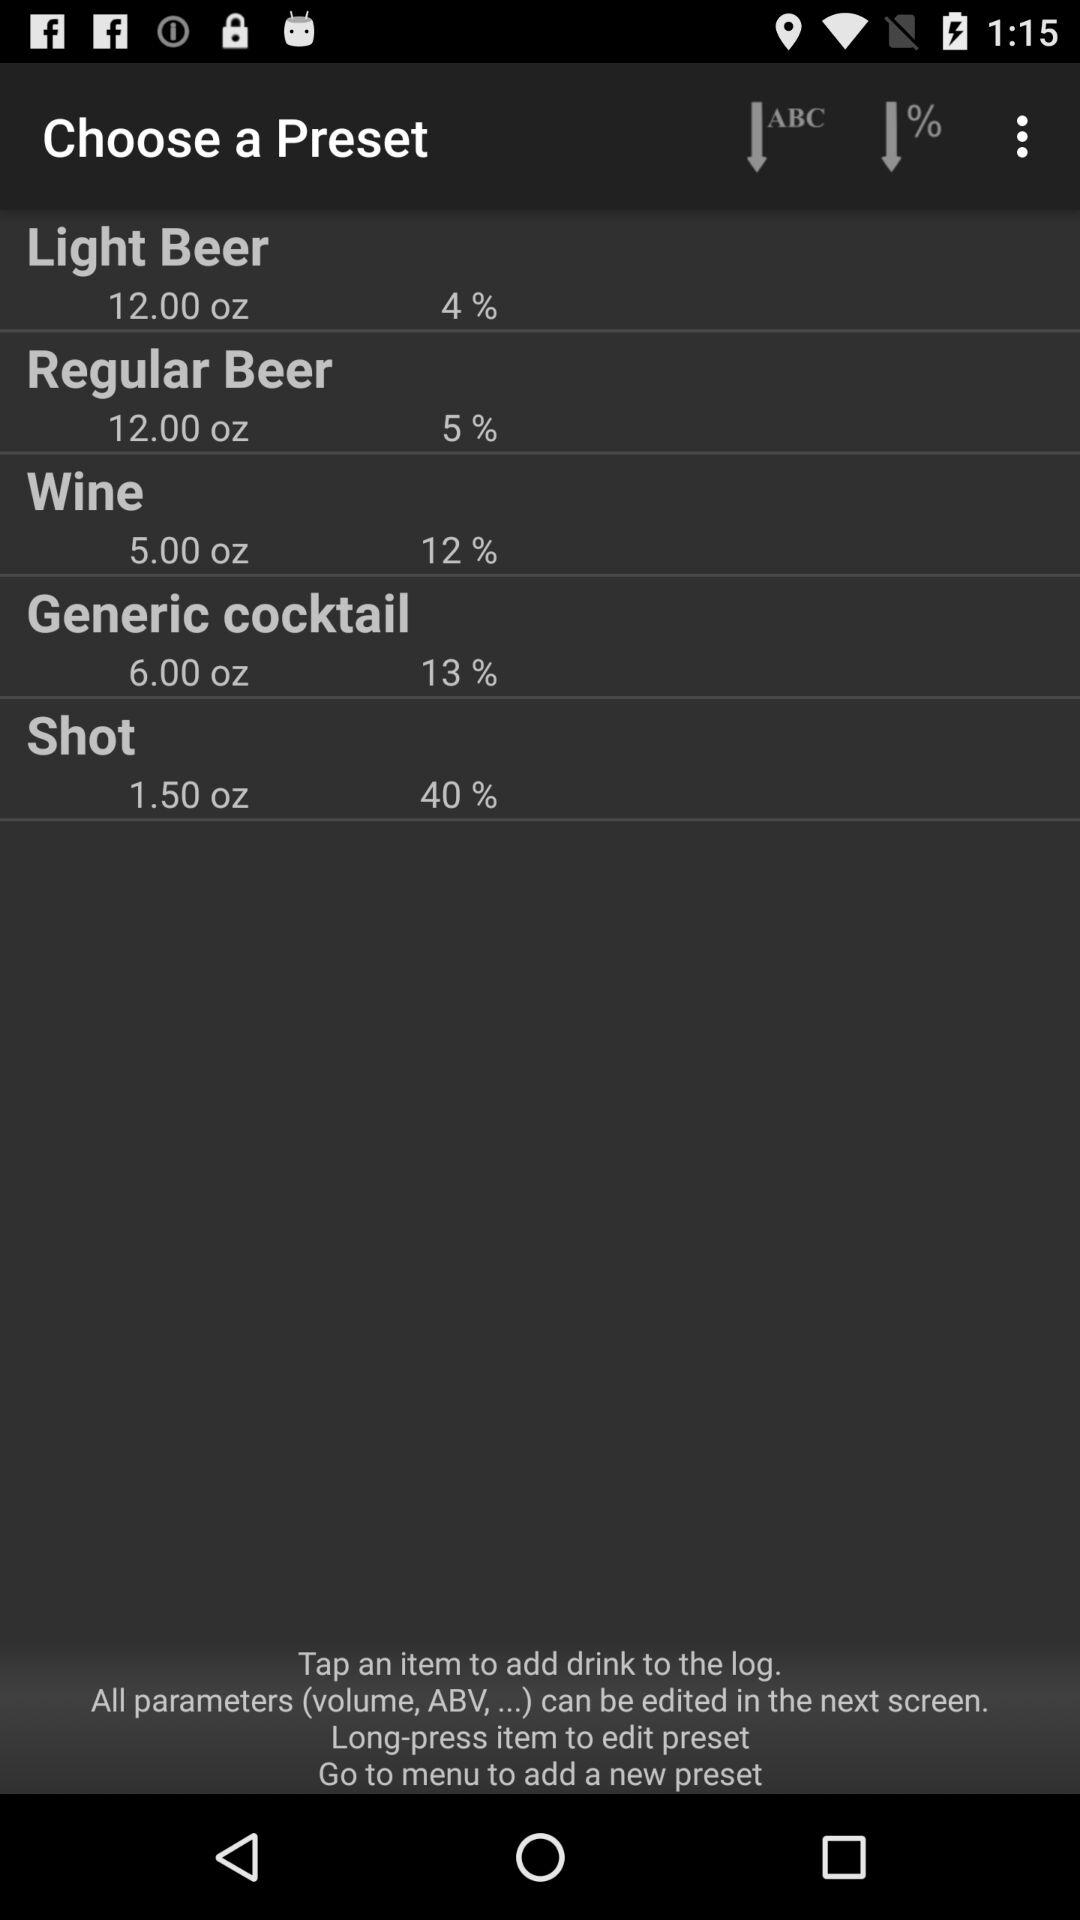What is the volume of "Regular Beer"? The volume is 12.00 oz. 